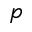<formula> <loc_0><loc_0><loc_500><loc_500>p</formula> 